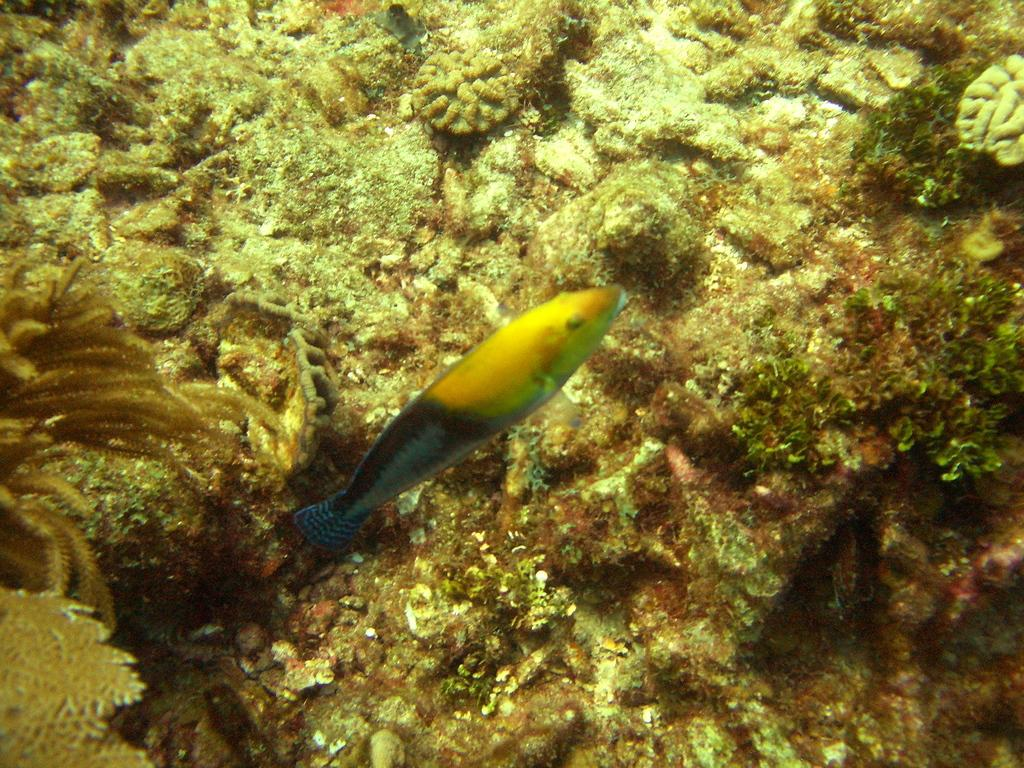What type of animal is in the image? There is a fish in the image. Where is the fish located? The fish is in the water. What can be seen in the background of the image? There is a coral reef in the image. What type of rabbit can be seen causing a class to be canceled in the image? There is no rabbit or class in the image; it features a fish in the water with a coral reef in the background. 